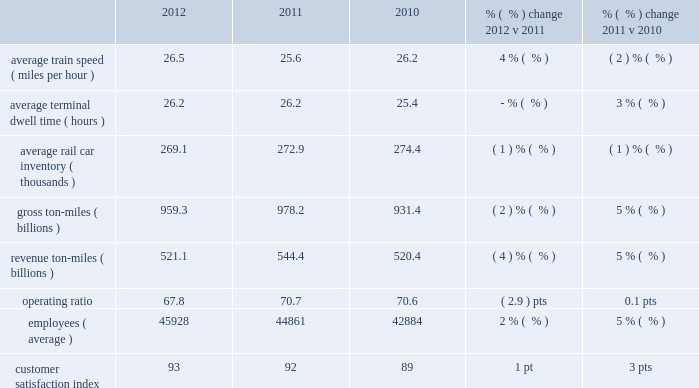Other income increased in 2011 versus 2010 due to higher gains from real estate sales , lower environmental costs associated with non-operating properties and the comparative impact of premiums paid for early redemption of long-term debt in the first quarter of 2010 .
Interest expense 2013 interest expense decreased in 2012 versus 2011 reflecting a lower effective interest rate in 2012 of 6.0% ( 6.0 % ) versus 6.2% ( 6.2 % ) in 2011 as the debt level did not materially change in 2012 .
Interest expense decreased in 2011 versus 2010 due to a lower weighted-average debt level of $ 9.2 billion versus $ 9.7 billion .
The effective interest rate was 6.2% ( 6.2 % ) in both 2011 and 2010 .
Income taxes 2013 higher pre-tax income increased income taxes in 2012 compared to 2011 .
Our effective tax rate for 2012 was relatively flat at 37.6% ( 37.6 % ) compared to 37.5% ( 37.5 % ) in 2011 .
Income taxes were higher in 2011 compared to 2010 , primarily driven by higher pre-tax income .
Our effective tax rate remained relatively flat at 37.5% ( 37.5 % ) in 2011 compared to 37.3% ( 37.3 % ) in 2010 .
Other operating/performance and financial statistics we report key performance measures weekly to the association of american railroads ( aar ) , including carloads , average daily inventory of freight cars on our system , average train speed , and average terminal dwell time .
We provide this data on our website at www.up.com/investors/reports/index.shtml .
Operating/performance statistics railroad performance measures reported to the aar , as well as other performance measures , are included in the table below : 2012 2011 2010 % (  % ) change 2012 v 2011 % (  % ) change 2011 v 2010 .
Average train speed 2013 average train speed is calculated by dividing train miles by hours operated on our main lines between terminals .
Average train speed , as reported to the association of american railroads ( aar ) , increased 4% ( 4 % ) in 2012 versus 2011 .
Efficient operations and relatively mild weather conditions during the year compared favorably to 2011 , during which severe winter weather , flooding , and extreme heat and drought affected various parts of our network .
We continued operating a fluid and efficient network while handling essentially the same volume and adjusting operations to accommodate increased capital project work on our network compared to 2011 .
The extreme weather challenges in addition to increased carloadings and traffic mix changes , led to a 2% ( 2 % ) decrease in average train speed in 2011 compared to 2010 .
Average terminal dwell time 2013 average terminal dwell time is the average time that a rail car spends at our terminals .
Lower average terminal dwell time improves asset utilization and service .
Average terminal dwell time remained flat in 2012 compared to 2011 , despite a shift in traffic mix to more manifest shipments , which require more switching at terminals .
Average terminal dwell time increased 3% ( 3 % ) in 2011 compared to 2010 .
Additional volume , weather challenges , track replacement programs , and a shift of traffic mix to more manifest shipments , which require additional terminal processing , all contributed to the increase .
Average rail car inventory 2013 average rail car inventory is the daily average number of rail cars on our lines , including rail cars in storage .
Lower average rail car inventory reduces congestion in our yards and sidings , which increases train speed , reduces average terminal dwell time , and improves rail car utilization .
Despite a shift in traffic mix from coal to shale-related and automotive shipments with longer .
What is the 2011 total interest expense in billions based on the weighted-average debt level and effective interest rate? 
Computations: (9.2 * 6.2%)
Answer: 0.5704. 